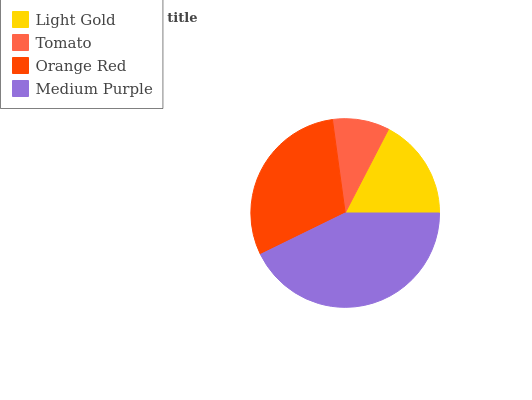Is Tomato the minimum?
Answer yes or no. Yes. Is Medium Purple the maximum?
Answer yes or no. Yes. Is Orange Red the minimum?
Answer yes or no. No. Is Orange Red the maximum?
Answer yes or no. No. Is Orange Red greater than Tomato?
Answer yes or no. Yes. Is Tomato less than Orange Red?
Answer yes or no. Yes. Is Tomato greater than Orange Red?
Answer yes or no. No. Is Orange Red less than Tomato?
Answer yes or no. No. Is Orange Red the high median?
Answer yes or no. Yes. Is Light Gold the low median?
Answer yes or no. Yes. Is Medium Purple the high median?
Answer yes or no. No. Is Medium Purple the low median?
Answer yes or no. No. 